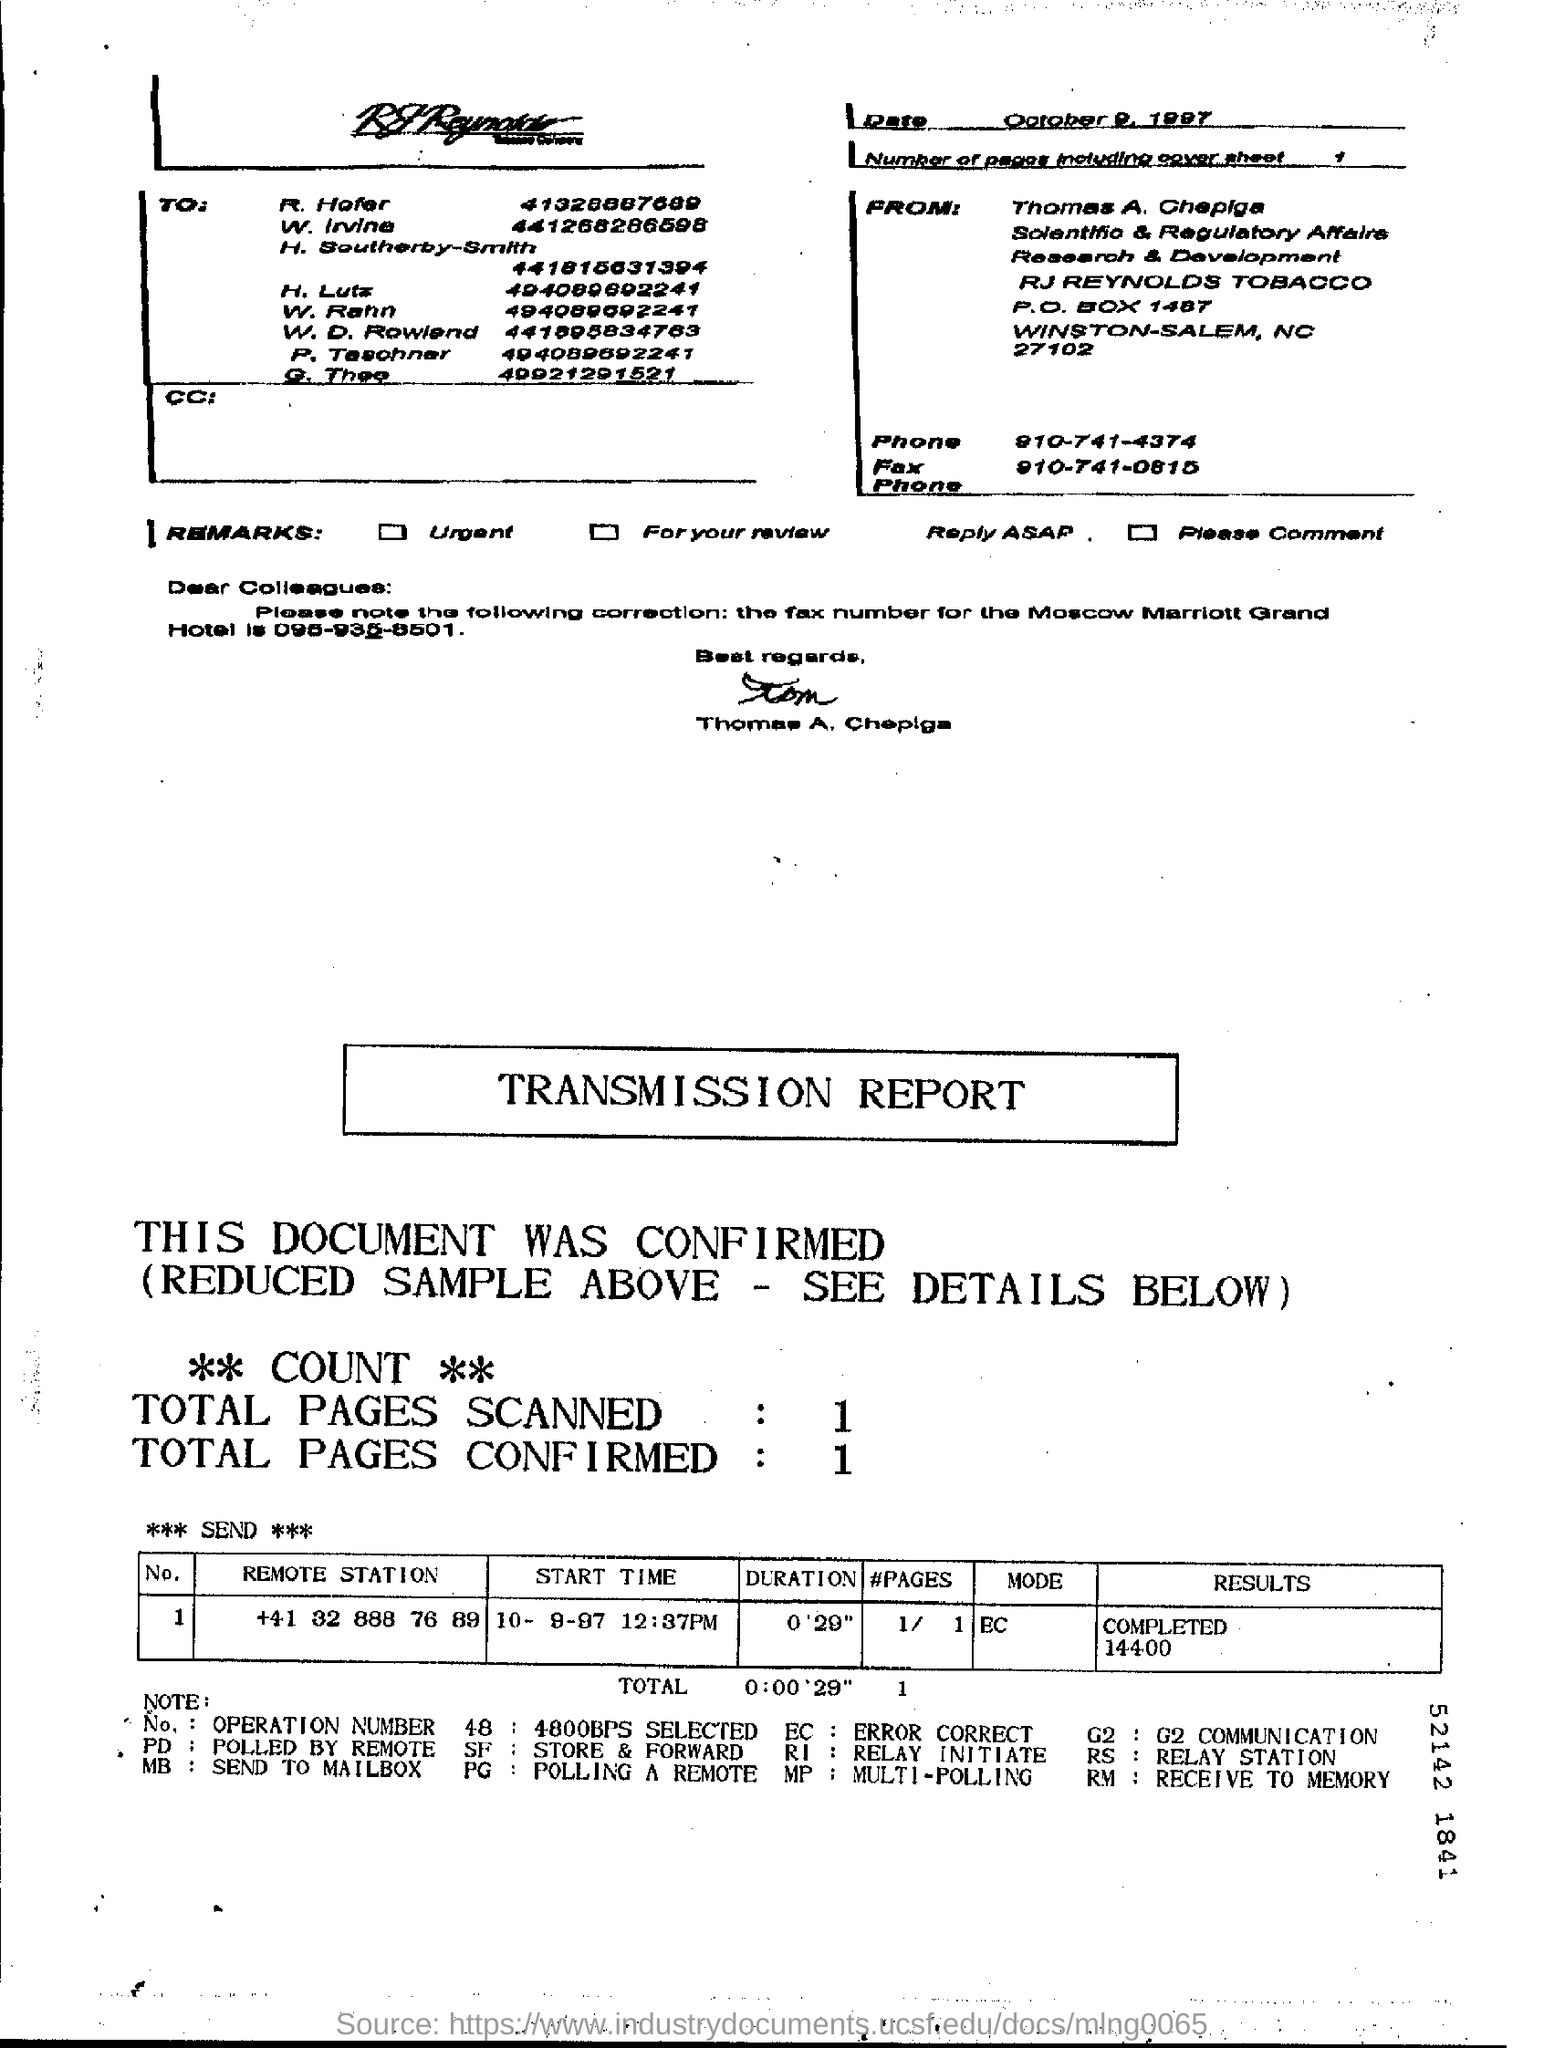Highlight a few significant elements in this photo. The phone number of Thomas A. Chapiga is 910-741-4374. 